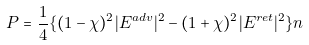<formula> <loc_0><loc_0><loc_500><loc_500>P = \frac { 1 } { 4 } \{ ( 1 - \chi ) ^ { 2 } | E ^ { a d v } | ^ { 2 } - ( 1 + \chi ) ^ { 2 } | E ^ { r e t } | ^ { 2 } \} n</formula> 